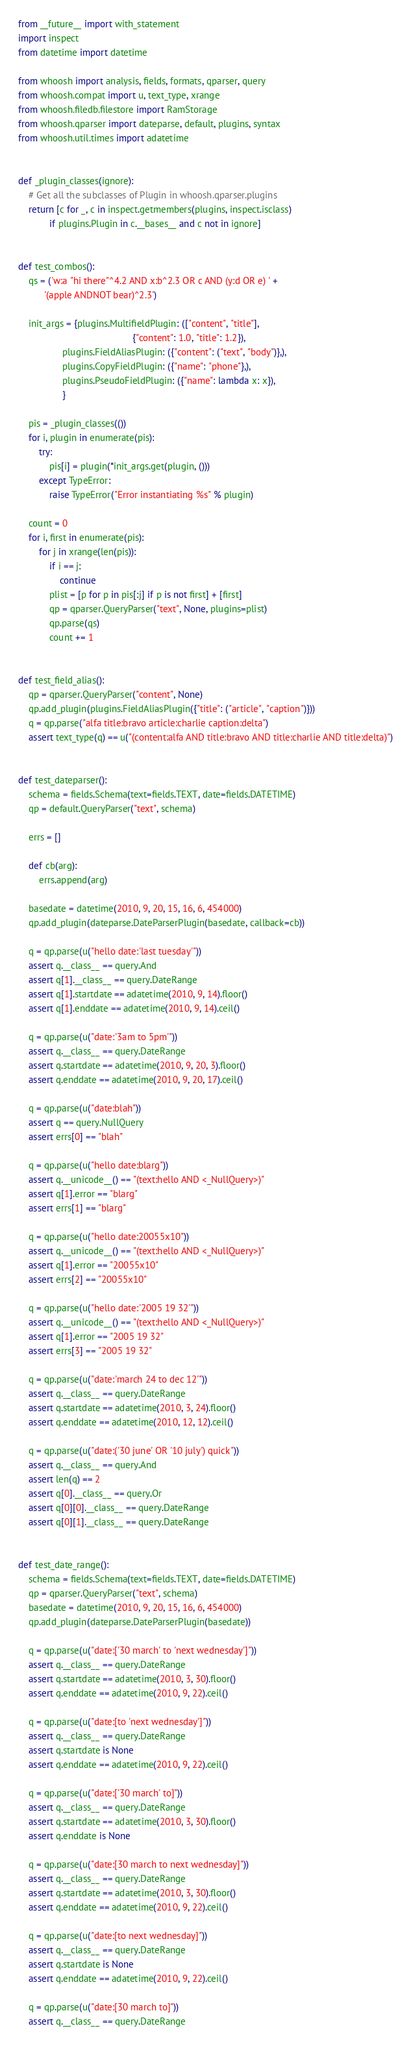Convert code to text. <code><loc_0><loc_0><loc_500><loc_500><_Python_>from __future__ import with_statement
import inspect
from datetime import datetime

from whoosh import analysis, fields, formats, qparser, query
from whoosh.compat import u, text_type, xrange
from whoosh.filedb.filestore import RamStorage
from whoosh.qparser import dateparse, default, plugins, syntax
from whoosh.util.times import adatetime


def _plugin_classes(ignore):
    # Get all the subclasses of Plugin in whoosh.qparser.plugins
    return [c for _, c in inspect.getmembers(plugins, inspect.isclass)
            if plugins.Plugin in c.__bases__ and c not in ignore]


def test_combos():
    qs = ('w:a "hi there"^4.2 AND x:b^2.3 OR c AND (y:d OR e) ' +
          '(apple ANDNOT bear)^2.3')

    init_args = {plugins.MultifieldPlugin: (["content", "title"],
                                            {"content": 1.0, "title": 1.2}),
                 plugins.FieldAliasPlugin: ({"content": ("text", "body")},),
                 plugins.CopyFieldPlugin: ({"name": "phone"},),
                 plugins.PseudoFieldPlugin: ({"name": lambda x: x}),
                 }

    pis = _plugin_classes(())
    for i, plugin in enumerate(pis):
        try:
            pis[i] = plugin(*init_args.get(plugin, ()))
        except TypeError:
            raise TypeError("Error instantiating %s" % plugin)

    count = 0
    for i, first in enumerate(pis):
        for j in xrange(len(pis)):
            if i == j:
                continue
            plist = [p for p in pis[:j] if p is not first] + [first]
            qp = qparser.QueryParser("text", None, plugins=plist)
            qp.parse(qs)
            count += 1


def test_field_alias():
    qp = qparser.QueryParser("content", None)
    qp.add_plugin(plugins.FieldAliasPlugin({"title": ("article", "caption")}))
    q = qp.parse("alfa title:bravo article:charlie caption:delta")
    assert text_type(q) == u("(content:alfa AND title:bravo AND title:charlie AND title:delta)")


def test_dateparser():
    schema = fields.Schema(text=fields.TEXT, date=fields.DATETIME)
    qp = default.QueryParser("text", schema)

    errs = []

    def cb(arg):
        errs.append(arg)

    basedate = datetime(2010, 9, 20, 15, 16, 6, 454000)
    qp.add_plugin(dateparse.DateParserPlugin(basedate, callback=cb))

    q = qp.parse(u("hello date:'last tuesday'"))
    assert q.__class__ == query.And
    assert q[1].__class__ == query.DateRange
    assert q[1].startdate == adatetime(2010, 9, 14).floor()
    assert q[1].enddate == adatetime(2010, 9, 14).ceil()

    q = qp.parse(u("date:'3am to 5pm'"))
    assert q.__class__ == query.DateRange
    assert q.startdate == adatetime(2010, 9, 20, 3).floor()
    assert q.enddate == adatetime(2010, 9, 20, 17).ceil()

    q = qp.parse(u("date:blah"))
    assert q == query.NullQuery
    assert errs[0] == "blah"

    q = qp.parse(u("hello date:blarg"))
    assert q.__unicode__() == "(text:hello AND <_NullQuery>)"
    assert q[1].error == "blarg"
    assert errs[1] == "blarg"

    q = qp.parse(u("hello date:20055x10"))
    assert q.__unicode__() == "(text:hello AND <_NullQuery>)"
    assert q[1].error == "20055x10"
    assert errs[2] == "20055x10"

    q = qp.parse(u("hello date:'2005 19 32'"))
    assert q.__unicode__() == "(text:hello AND <_NullQuery>)"
    assert q[1].error == "2005 19 32"
    assert errs[3] == "2005 19 32"

    q = qp.parse(u("date:'march 24 to dec 12'"))
    assert q.__class__ == query.DateRange
    assert q.startdate == adatetime(2010, 3, 24).floor()
    assert q.enddate == adatetime(2010, 12, 12).ceil()

    q = qp.parse(u("date:('30 june' OR '10 july') quick"))
    assert q.__class__ == query.And
    assert len(q) == 2
    assert q[0].__class__ == query.Or
    assert q[0][0].__class__ == query.DateRange
    assert q[0][1].__class__ == query.DateRange


def test_date_range():
    schema = fields.Schema(text=fields.TEXT, date=fields.DATETIME)
    qp = qparser.QueryParser("text", schema)
    basedate = datetime(2010, 9, 20, 15, 16, 6, 454000)
    qp.add_plugin(dateparse.DateParserPlugin(basedate))

    q = qp.parse(u("date:['30 march' to 'next wednesday']"))
    assert q.__class__ == query.DateRange
    assert q.startdate == adatetime(2010, 3, 30).floor()
    assert q.enddate == adatetime(2010, 9, 22).ceil()

    q = qp.parse(u("date:[to 'next wednesday']"))
    assert q.__class__ == query.DateRange
    assert q.startdate is None
    assert q.enddate == adatetime(2010, 9, 22).ceil()

    q = qp.parse(u("date:['30 march' to]"))
    assert q.__class__ == query.DateRange
    assert q.startdate == adatetime(2010, 3, 30).floor()
    assert q.enddate is None

    q = qp.parse(u("date:[30 march to next wednesday]"))
    assert q.__class__ == query.DateRange
    assert q.startdate == adatetime(2010, 3, 30).floor()
    assert q.enddate == adatetime(2010, 9, 22).ceil()

    q = qp.parse(u("date:[to next wednesday]"))
    assert q.__class__ == query.DateRange
    assert q.startdate is None
    assert q.enddate == adatetime(2010, 9, 22).ceil()

    q = qp.parse(u("date:[30 march to]"))
    assert q.__class__ == query.DateRange</code> 